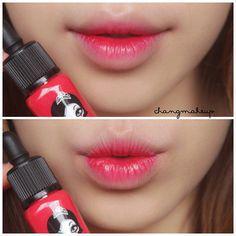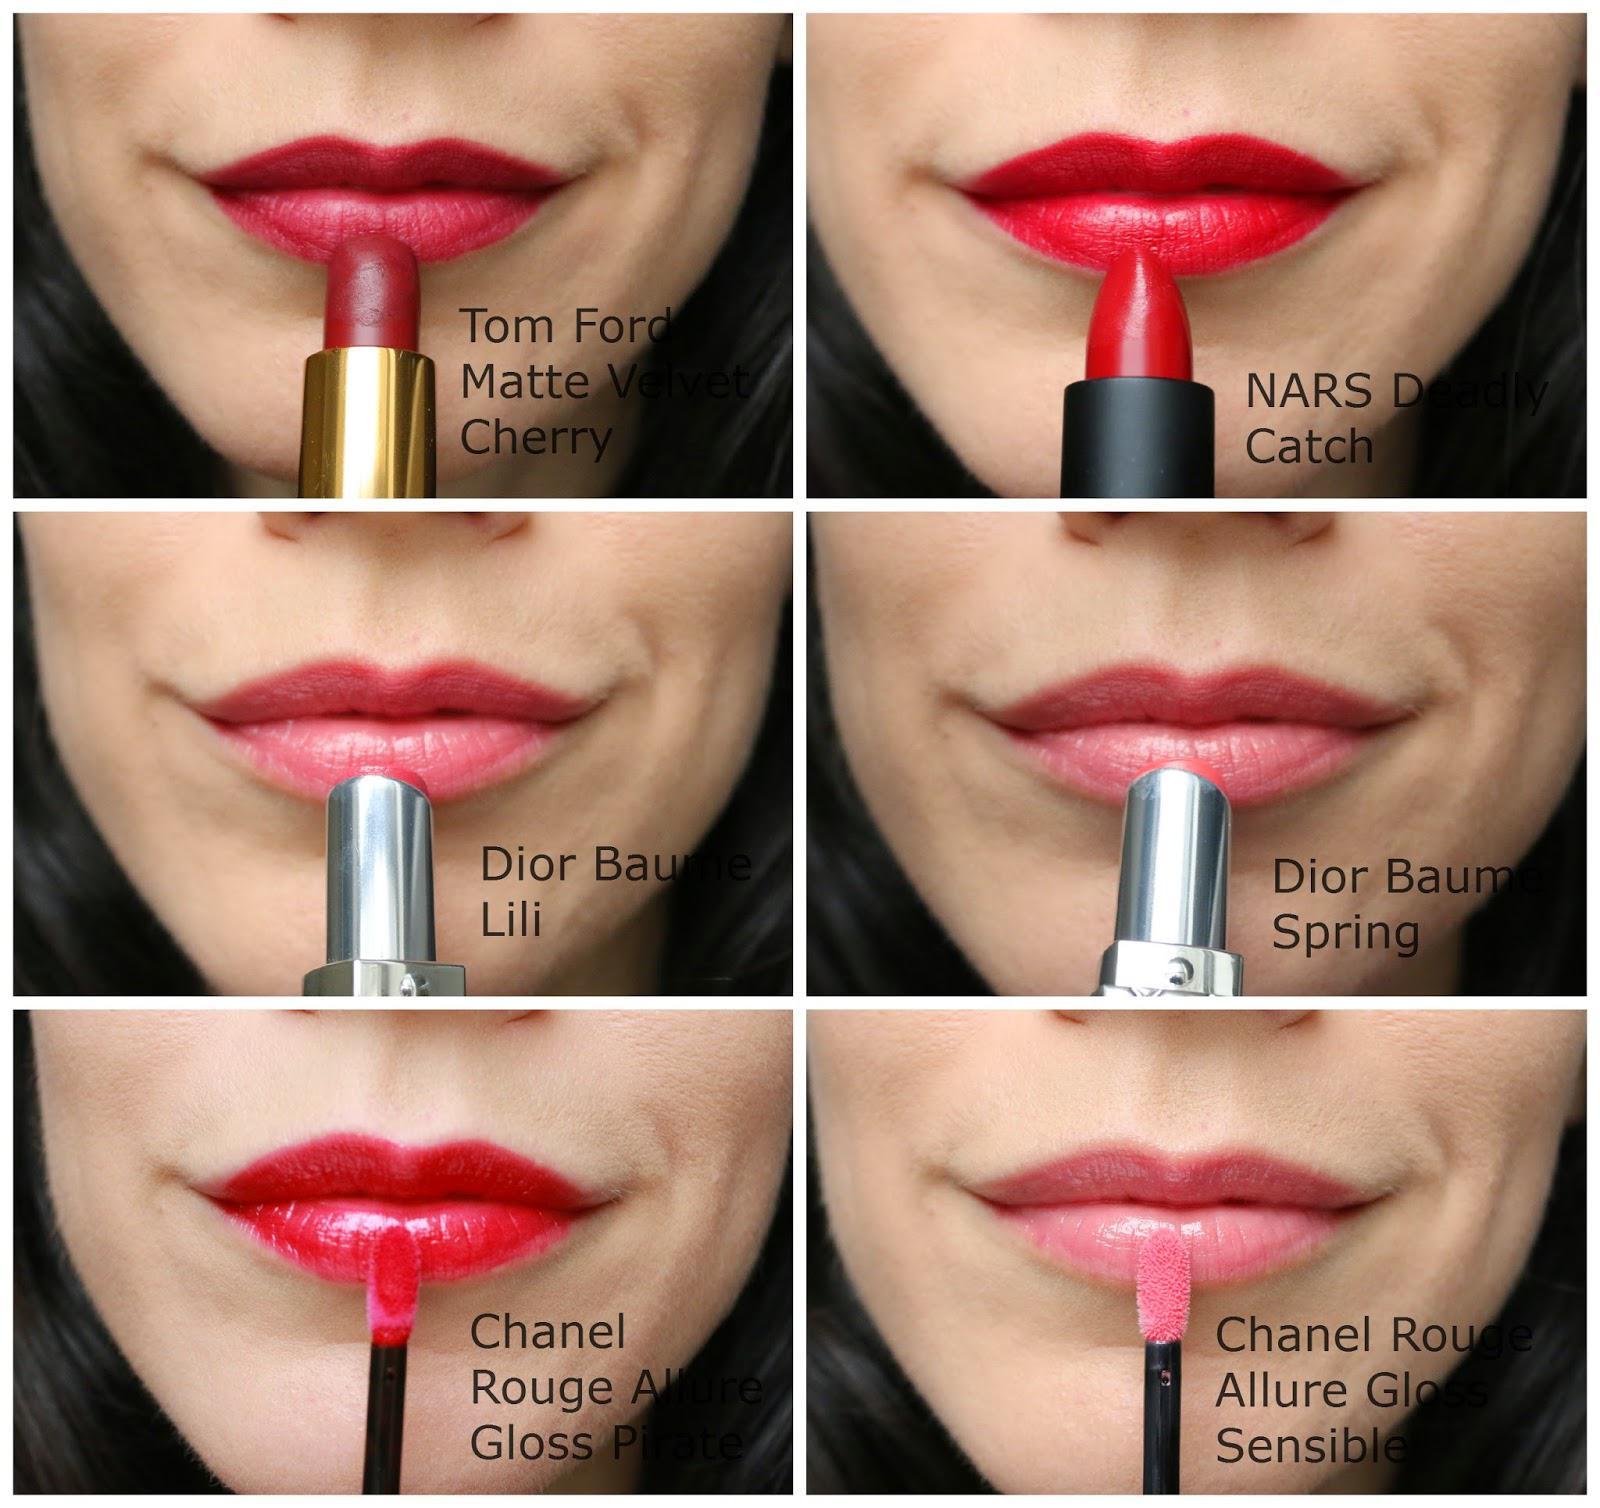The first image is the image on the left, the second image is the image on the right. Evaluate the accuracy of this statement regarding the images: "A woman's teeth are visible in one of the images.". Is it true? Answer yes or no. No. The first image is the image on the left, the second image is the image on the right. For the images displayed, is the sentence "Tinted lips and smears of different lipstick colors are shown, along with containers of lip makeup." factually correct? Answer yes or no. No. 